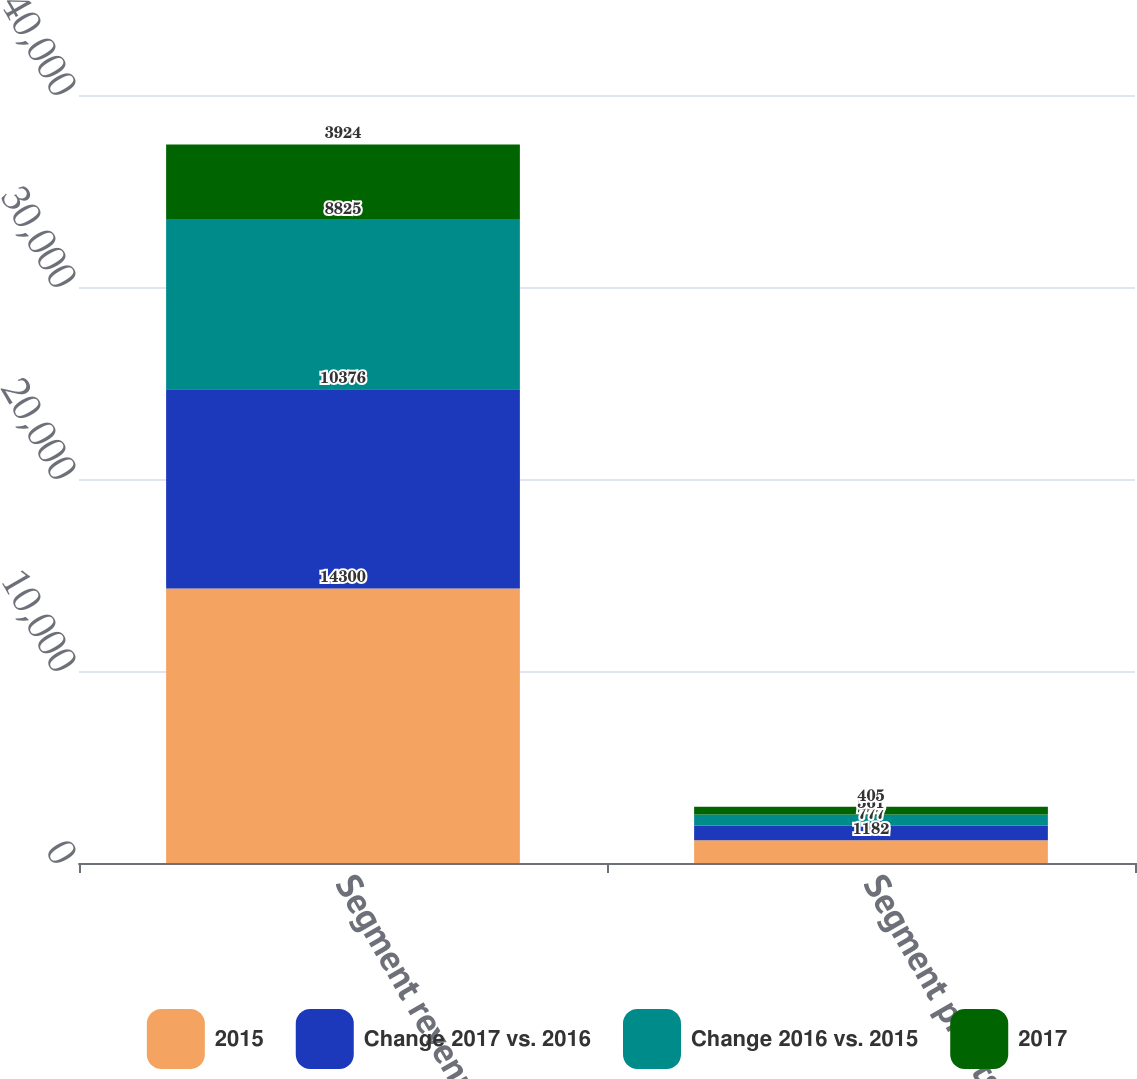Convert chart. <chart><loc_0><loc_0><loc_500><loc_500><stacked_bar_chart><ecel><fcel>Segment revenues<fcel>Segment profits<nl><fcel>2015<fcel>14300<fcel>1182<nl><fcel>Change 2017 vs. 2016<fcel>10376<fcel>777<nl><fcel>Change 2016 vs. 2015<fcel>8825<fcel>561<nl><fcel>2017<fcel>3924<fcel>405<nl></chart> 